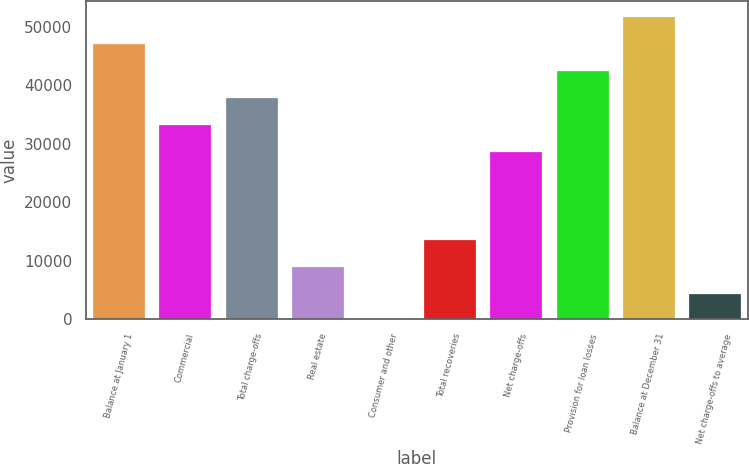Convert chart to OTSL. <chart><loc_0><loc_0><loc_500><loc_500><bar_chart><fcel>Balance at January 1<fcel>Commercial<fcel>Total charge-offs<fcel>Real estate<fcel>Consumer and other<fcel>Total recoveries<fcel>Net charge-offs<fcel>Provision for loan losses<fcel>Balance at December 31<fcel>Net charge-offs to average<nl><fcel>47258.6<fcel>33458.9<fcel>38058.8<fcel>9200.8<fcel>1<fcel>13800.7<fcel>28859<fcel>42658.7<fcel>51858.5<fcel>4600.9<nl></chart> 